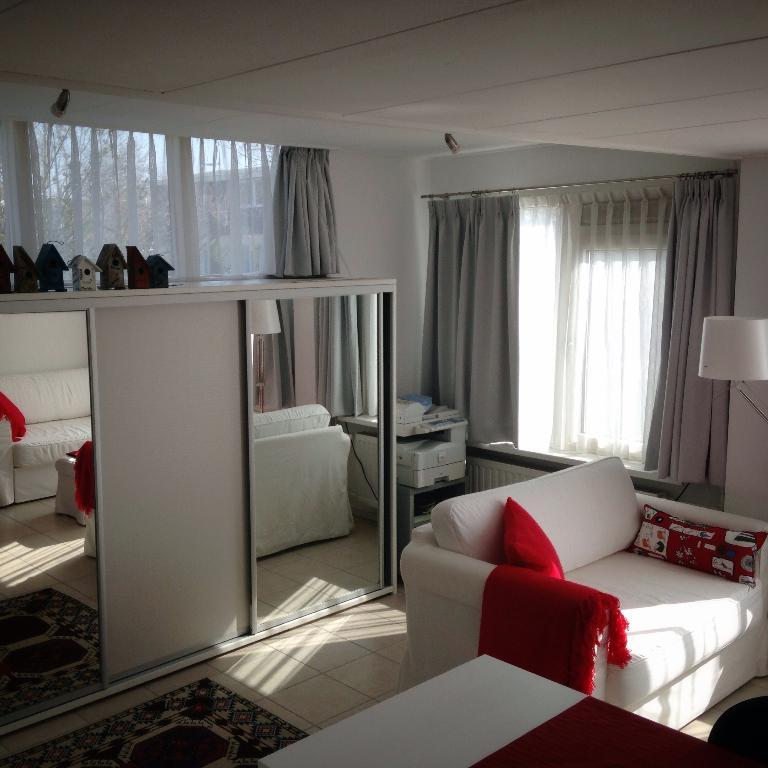What type of furniture is in the room with pillows? There is a sofa with pillows in the room. What type of lighting is present in the room? There is a lamp in the room. What type of window treatment is present in the room? There are curtains on the window. What type of device is in the room for printing? There is a printer in the room. What type of reflective surface is in the room? There is a mirror in the room. What type of items are in the room for children to play with? There are toys in the room. What type of patch is visible on the sofa in the room? There is no patch visible on the sofa in the room. What type of stage is present in the room for performances? There is no stage present in the room; it is a regular room with a sofa, lamp, curtains, printer, mirror, and toys. 